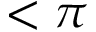<formula> <loc_0><loc_0><loc_500><loc_500>< \pi</formula> 